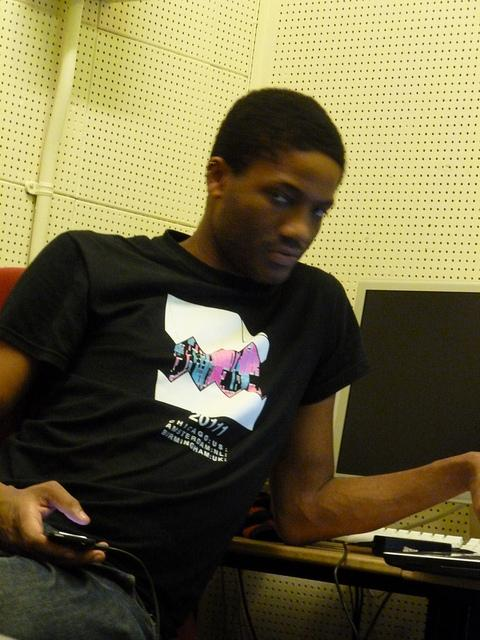What is the purpose of the holes behind him? Please explain your reasoning. hanging things. The holes allow things to be hung from them. 